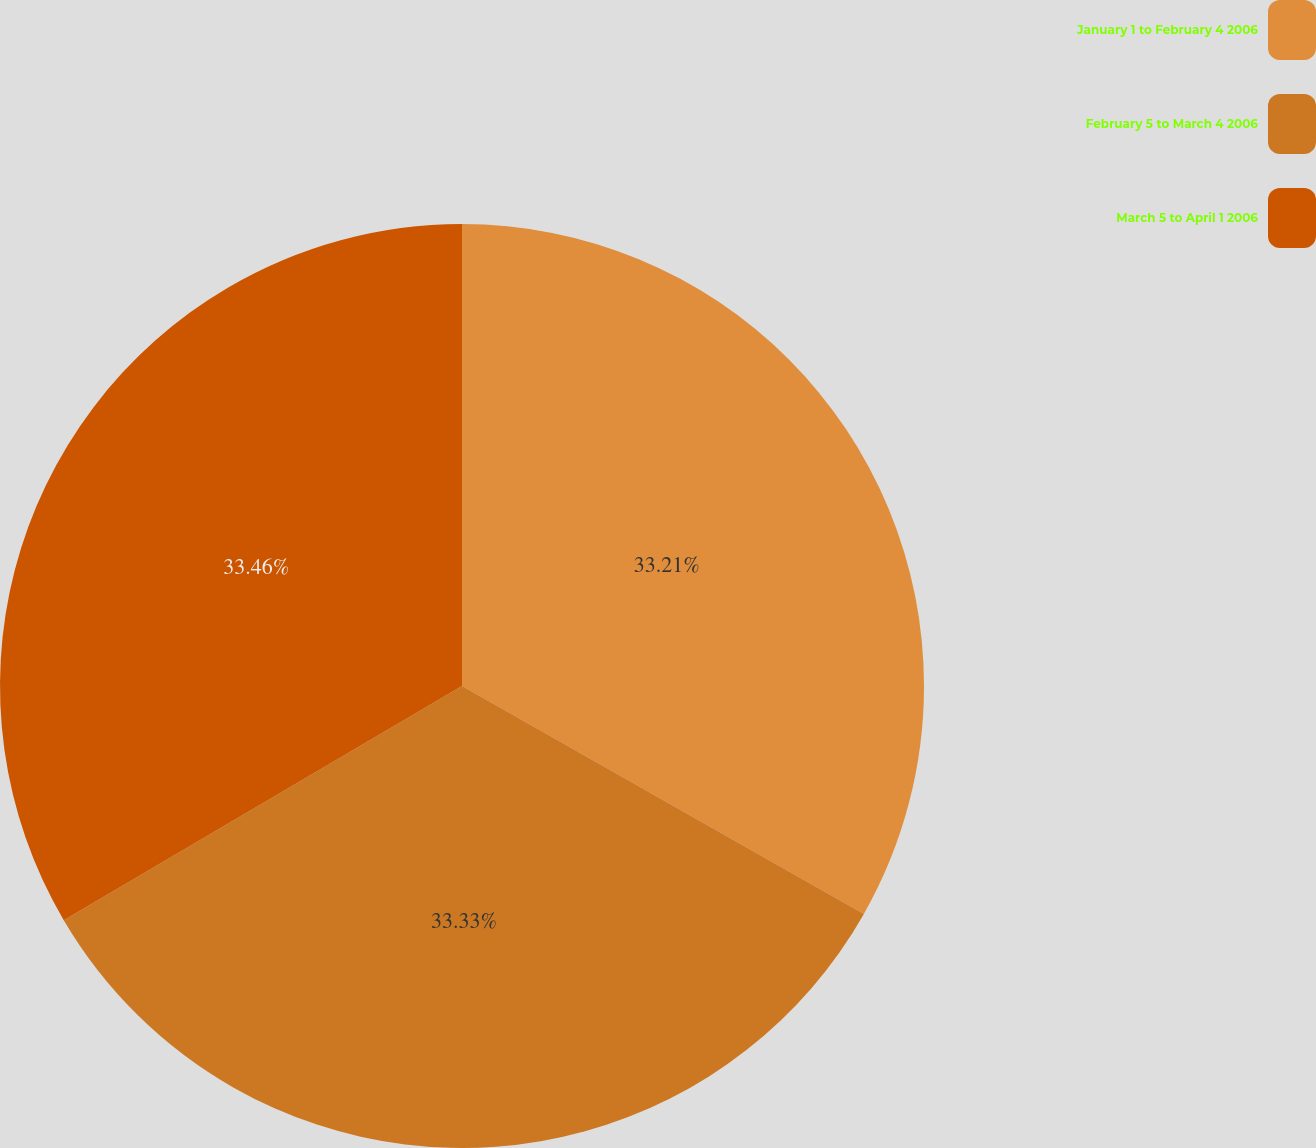Convert chart to OTSL. <chart><loc_0><loc_0><loc_500><loc_500><pie_chart><fcel>January 1 to February 4 2006<fcel>February 5 to March 4 2006<fcel>March 5 to April 1 2006<nl><fcel>33.21%<fcel>33.33%<fcel>33.46%<nl></chart> 